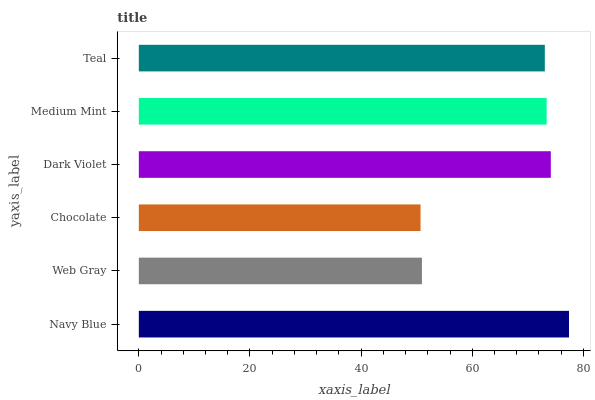Is Chocolate the minimum?
Answer yes or no. Yes. Is Navy Blue the maximum?
Answer yes or no. Yes. Is Web Gray the minimum?
Answer yes or no. No. Is Web Gray the maximum?
Answer yes or no. No. Is Navy Blue greater than Web Gray?
Answer yes or no. Yes. Is Web Gray less than Navy Blue?
Answer yes or no. Yes. Is Web Gray greater than Navy Blue?
Answer yes or no. No. Is Navy Blue less than Web Gray?
Answer yes or no. No. Is Medium Mint the high median?
Answer yes or no. Yes. Is Teal the low median?
Answer yes or no. Yes. Is Chocolate the high median?
Answer yes or no. No. Is Web Gray the low median?
Answer yes or no. No. 